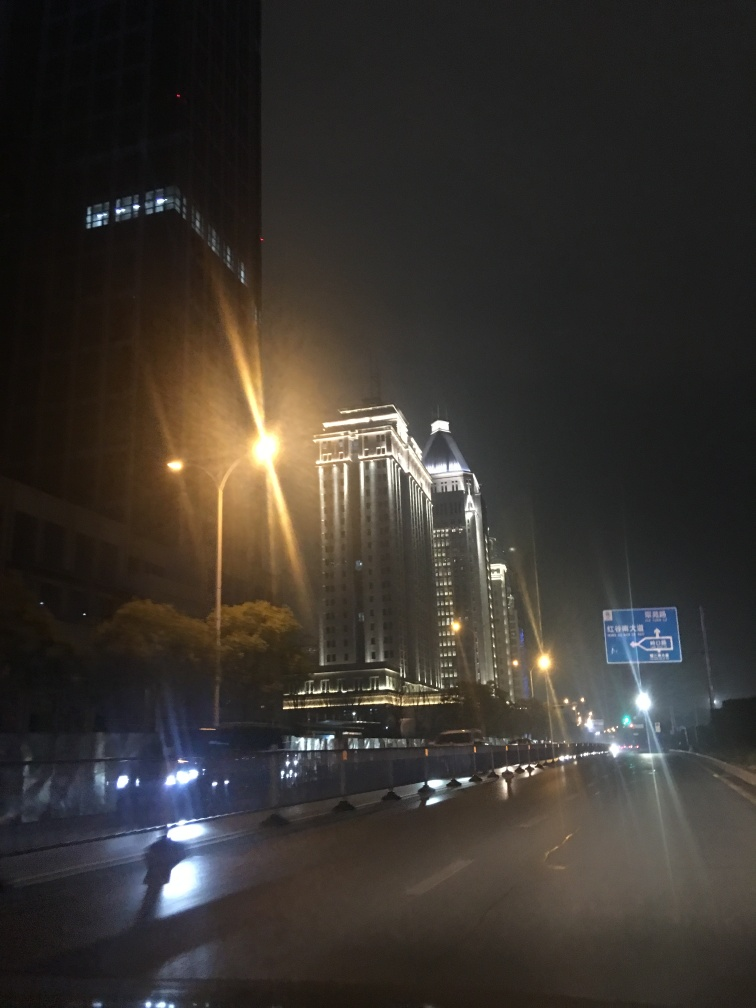What does this image depict?
A. City skyline
B. Highway scenery
C. Beach view The image depicts a nighttime view of a city skyline, showcasing illuminated buildings and streetlights. A road runs in the foreground, indicating the presence of highway scenery as well. Therefore, while the primary subject is the city skyline, there is also an element of highway scenery involved. 